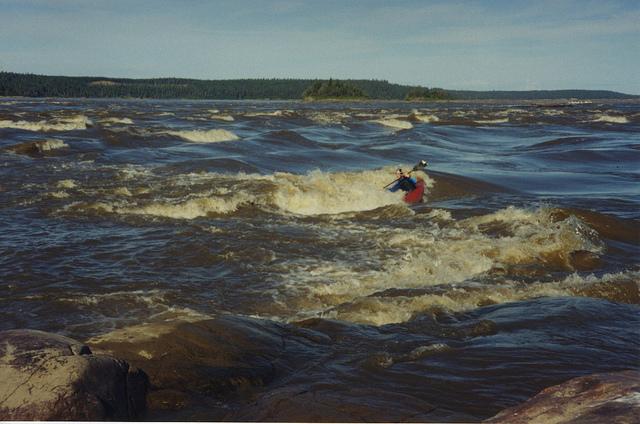Is the shore rocky?
Write a very short answer. Yes. What color is the water?
Quick response, please. Brown. How many people are in the water?
Give a very brief answer. 1. Will this person be wet?
Quick response, please. Yes. 